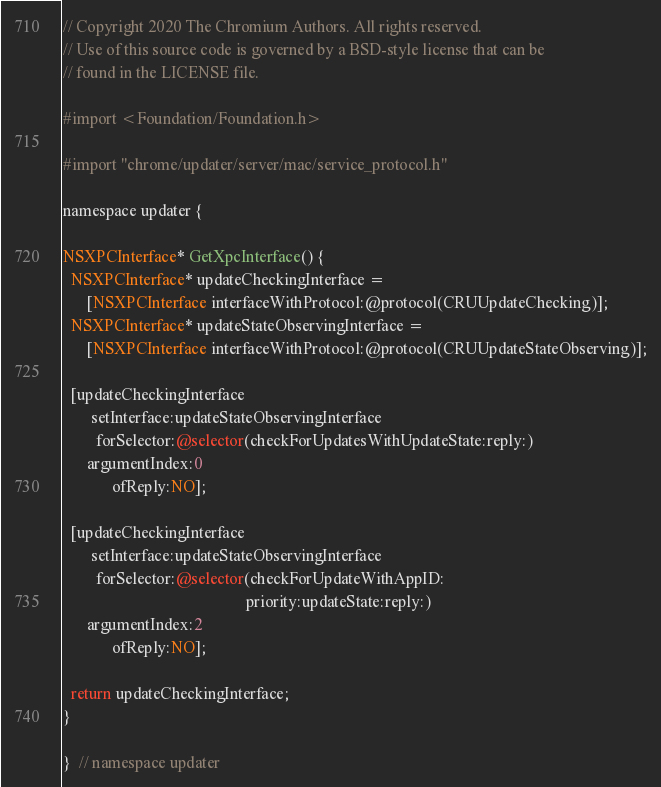<code> <loc_0><loc_0><loc_500><loc_500><_ObjectiveC_>// Copyright 2020 The Chromium Authors. All rights reserved.
// Use of this source code is governed by a BSD-style license that can be
// found in the LICENSE file.

#import <Foundation/Foundation.h>

#import "chrome/updater/server/mac/service_protocol.h"

namespace updater {

NSXPCInterface* GetXpcInterface() {
  NSXPCInterface* updateCheckingInterface =
      [NSXPCInterface interfaceWithProtocol:@protocol(CRUUpdateChecking)];
  NSXPCInterface* updateStateObservingInterface =
      [NSXPCInterface interfaceWithProtocol:@protocol(CRUUpdateStateObserving)];

  [updateCheckingInterface
       setInterface:updateStateObservingInterface
        forSelector:@selector(checkForUpdatesWithUpdateState:reply:)
      argumentIndex:0
            ofReply:NO];

  [updateCheckingInterface
       setInterface:updateStateObservingInterface
        forSelector:@selector(checkForUpdateWithAppID:
                                             priority:updateState:reply:)
      argumentIndex:2
            ofReply:NO];

  return updateCheckingInterface;
}

}  // namespace updater
</code> 